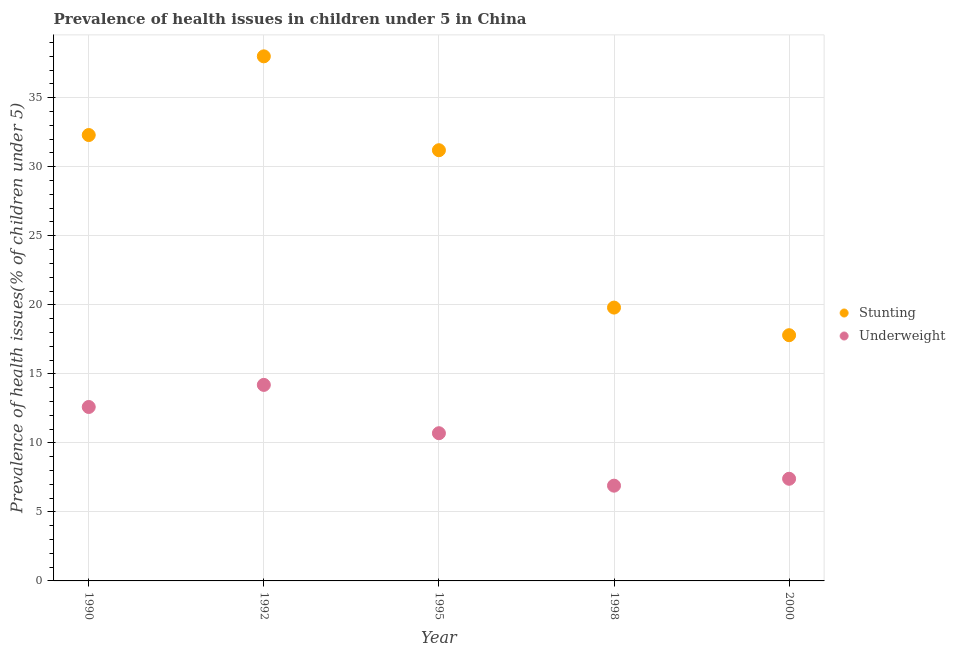What is the percentage of underweight children in 1990?
Offer a very short reply. 12.6. Across all years, what is the maximum percentage of underweight children?
Your answer should be compact. 14.2. Across all years, what is the minimum percentage of underweight children?
Offer a very short reply. 6.9. What is the total percentage of stunted children in the graph?
Ensure brevity in your answer.  139.1. What is the difference between the percentage of underweight children in 1992 and that in 1995?
Offer a terse response. 3.5. What is the difference between the percentage of stunted children in 2000 and the percentage of underweight children in 1992?
Offer a very short reply. 3.6. What is the average percentage of underweight children per year?
Offer a very short reply. 10.36. In the year 1990, what is the difference between the percentage of underweight children and percentage of stunted children?
Provide a short and direct response. -19.7. In how many years, is the percentage of underweight children greater than 14 %?
Keep it short and to the point. 1. What is the ratio of the percentage of underweight children in 1992 to that in 1995?
Ensure brevity in your answer.  1.33. Is the percentage of stunted children in 1990 less than that in 1998?
Keep it short and to the point. No. What is the difference between the highest and the second highest percentage of underweight children?
Provide a short and direct response. 1.6. What is the difference between the highest and the lowest percentage of underweight children?
Your response must be concise. 7.3. Is the percentage of stunted children strictly greater than the percentage of underweight children over the years?
Provide a short and direct response. Yes. How many years are there in the graph?
Your answer should be compact. 5. Does the graph contain grids?
Your response must be concise. Yes. What is the title of the graph?
Provide a short and direct response. Prevalence of health issues in children under 5 in China. What is the label or title of the X-axis?
Provide a short and direct response. Year. What is the label or title of the Y-axis?
Your answer should be compact. Prevalence of health issues(% of children under 5). What is the Prevalence of health issues(% of children under 5) in Stunting in 1990?
Your answer should be very brief. 32.3. What is the Prevalence of health issues(% of children under 5) in Underweight in 1990?
Keep it short and to the point. 12.6. What is the Prevalence of health issues(% of children under 5) in Underweight in 1992?
Offer a terse response. 14.2. What is the Prevalence of health issues(% of children under 5) in Stunting in 1995?
Ensure brevity in your answer.  31.2. What is the Prevalence of health issues(% of children under 5) of Underweight in 1995?
Ensure brevity in your answer.  10.7. What is the Prevalence of health issues(% of children under 5) of Stunting in 1998?
Make the answer very short. 19.8. What is the Prevalence of health issues(% of children under 5) of Underweight in 1998?
Offer a very short reply. 6.9. What is the Prevalence of health issues(% of children under 5) of Stunting in 2000?
Offer a terse response. 17.8. What is the Prevalence of health issues(% of children under 5) in Underweight in 2000?
Your answer should be compact. 7.4. Across all years, what is the maximum Prevalence of health issues(% of children under 5) in Stunting?
Make the answer very short. 38. Across all years, what is the maximum Prevalence of health issues(% of children under 5) of Underweight?
Give a very brief answer. 14.2. Across all years, what is the minimum Prevalence of health issues(% of children under 5) in Stunting?
Make the answer very short. 17.8. Across all years, what is the minimum Prevalence of health issues(% of children under 5) in Underweight?
Make the answer very short. 6.9. What is the total Prevalence of health issues(% of children under 5) of Stunting in the graph?
Your response must be concise. 139.1. What is the total Prevalence of health issues(% of children under 5) in Underweight in the graph?
Offer a very short reply. 51.8. What is the difference between the Prevalence of health issues(% of children under 5) in Stunting in 1990 and that in 1992?
Provide a succinct answer. -5.7. What is the difference between the Prevalence of health issues(% of children under 5) of Underweight in 1990 and that in 1992?
Your answer should be compact. -1.6. What is the difference between the Prevalence of health issues(% of children under 5) in Underweight in 1990 and that in 1995?
Provide a succinct answer. 1.9. What is the difference between the Prevalence of health issues(% of children under 5) of Stunting in 1990 and that in 2000?
Your answer should be very brief. 14.5. What is the difference between the Prevalence of health issues(% of children under 5) in Underweight in 1992 and that in 1998?
Keep it short and to the point. 7.3. What is the difference between the Prevalence of health issues(% of children under 5) in Stunting in 1992 and that in 2000?
Ensure brevity in your answer.  20.2. What is the difference between the Prevalence of health issues(% of children under 5) of Underweight in 1992 and that in 2000?
Provide a short and direct response. 6.8. What is the difference between the Prevalence of health issues(% of children under 5) in Stunting in 1995 and that in 1998?
Make the answer very short. 11.4. What is the difference between the Prevalence of health issues(% of children under 5) in Underweight in 1995 and that in 1998?
Ensure brevity in your answer.  3.8. What is the difference between the Prevalence of health issues(% of children under 5) in Stunting in 1995 and that in 2000?
Provide a succinct answer. 13.4. What is the difference between the Prevalence of health issues(% of children under 5) of Stunting in 1998 and that in 2000?
Your response must be concise. 2. What is the difference between the Prevalence of health issues(% of children under 5) of Stunting in 1990 and the Prevalence of health issues(% of children under 5) of Underweight in 1995?
Make the answer very short. 21.6. What is the difference between the Prevalence of health issues(% of children under 5) in Stunting in 1990 and the Prevalence of health issues(% of children under 5) in Underweight in 1998?
Your answer should be compact. 25.4. What is the difference between the Prevalence of health issues(% of children under 5) of Stunting in 1990 and the Prevalence of health issues(% of children under 5) of Underweight in 2000?
Your answer should be compact. 24.9. What is the difference between the Prevalence of health issues(% of children under 5) of Stunting in 1992 and the Prevalence of health issues(% of children under 5) of Underweight in 1995?
Give a very brief answer. 27.3. What is the difference between the Prevalence of health issues(% of children under 5) in Stunting in 1992 and the Prevalence of health issues(% of children under 5) in Underweight in 1998?
Your response must be concise. 31.1. What is the difference between the Prevalence of health issues(% of children under 5) in Stunting in 1992 and the Prevalence of health issues(% of children under 5) in Underweight in 2000?
Your response must be concise. 30.6. What is the difference between the Prevalence of health issues(% of children under 5) of Stunting in 1995 and the Prevalence of health issues(% of children under 5) of Underweight in 1998?
Offer a very short reply. 24.3. What is the difference between the Prevalence of health issues(% of children under 5) of Stunting in 1995 and the Prevalence of health issues(% of children under 5) of Underweight in 2000?
Provide a short and direct response. 23.8. What is the difference between the Prevalence of health issues(% of children under 5) in Stunting in 1998 and the Prevalence of health issues(% of children under 5) in Underweight in 2000?
Offer a very short reply. 12.4. What is the average Prevalence of health issues(% of children under 5) in Stunting per year?
Keep it short and to the point. 27.82. What is the average Prevalence of health issues(% of children under 5) in Underweight per year?
Provide a succinct answer. 10.36. In the year 1990, what is the difference between the Prevalence of health issues(% of children under 5) of Stunting and Prevalence of health issues(% of children under 5) of Underweight?
Your response must be concise. 19.7. In the year 1992, what is the difference between the Prevalence of health issues(% of children under 5) in Stunting and Prevalence of health issues(% of children under 5) in Underweight?
Your answer should be very brief. 23.8. In the year 1998, what is the difference between the Prevalence of health issues(% of children under 5) of Stunting and Prevalence of health issues(% of children under 5) of Underweight?
Provide a short and direct response. 12.9. What is the ratio of the Prevalence of health issues(% of children under 5) of Stunting in 1990 to that in 1992?
Provide a succinct answer. 0.85. What is the ratio of the Prevalence of health issues(% of children under 5) of Underweight in 1990 to that in 1992?
Your answer should be very brief. 0.89. What is the ratio of the Prevalence of health issues(% of children under 5) of Stunting in 1990 to that in 1995?
Provide a short and direct response. 1.04. What is the ratio of the Prevalence of health issues(% of children under 5) in Underweight in 1990 to that in 1995?
Your answer should be very brief. 1.18. What is the ratio of the Prevalence of health issues(% of children under 5) of Stunting in 1990 to that in 1998?
Provide a succinct answer. 1.63. What is the ratio of the Prevalence of health issues(% of children under 5) of Underweight in 1990 to that in 1998?
Offer a very short reply. 1.83. What is the ratio of the Prevalence of health issues(% of children under 5) of Stunting in 1990 to that in 2000?
Offer a very short reply. 1.81. What is the ratio of the Prevalence of health issues(% of children under 5) in Underweight in 1990 to that in 2000?
Keep it short and to the point. 1.7. What is the ratio of the Prevalence of health issues(% of children under 5) of Stunting in 1992 to that in 1995?
Make the answer very short. 1.22. What is the ratio of the Prevalence of health issues(% of children under 5) in Underweight in 1992 to that in 1995?
Offer a terse response. 1.33. What is the ratio of the Prevalence of health issues(% of children under 5) of Stunting in 1992 to that in 1998?
Give a very brief answer. 1.92. What is the ratio of the Prevalence of health issues(% of children under 5) of Underweight in 1992 to that in 1998?
Your response must be concise. 2.06. What is the ratio of the Prevalence of health issues(% of children under 5) of Stunting in 1992 to that in 2000?
Keep it short and to the point. 2.13. What is the ratio of the Prevalence of health issues(% of children under 5) in Underweight in 1992 to that in 2000?
Offer a terse response. 1.92. What is the ratio of the Prevalence of health issues(% of children under 5) of Stunting in 1995 to that in 1998?
Provide a short and direct response. 1.58. What is the ratio of the Prevalence of health issues(% of children under 5) in Underweight in 1995 to that in 1998?
Your response must be concise. 1.55. What is the ratio of the Prevalence of health issues(% of children under 5) of Stunting in 1995 to that in 2000?
Your answer should be compact. 1.75. What is the ratio of the Prevalence of health issues(% of children under 5) of Underweight in 1995 to that in 2000?
Provide a short and direct response. 1.45. What is the ratio of the Prevalence of health issues(% of children under 5) in Stunting in 1998 to that in 2000?
Provide a succinct answer. 1.11. What is the ratio of the Prevalence of health issues(% of children under 5) of Underweight in 1998 to that in 2000?
Your answer should be compact. 0.93. What is the difference between the highest and the lowest Prevalence of health issues(% of children under 5) in Stunting?
Give a very brief answer. 20.2. What is the difference between the highest and the lowest Prevalence of health issues(% of children under 5) of Underweight?
Your answer should be very brief. 7.3. 